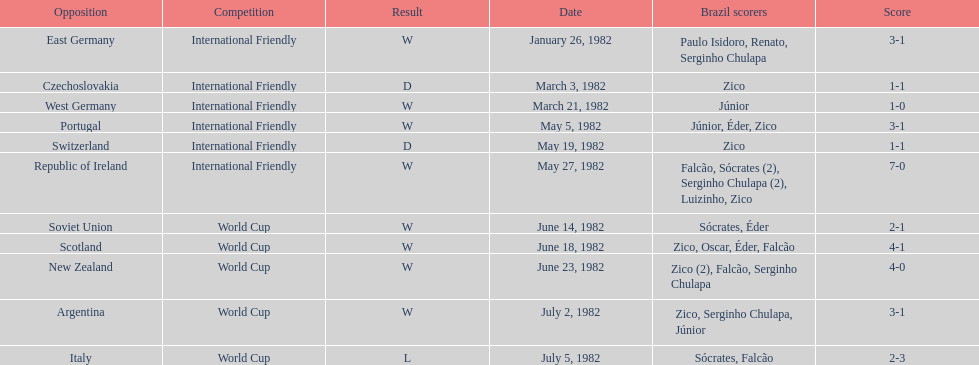Parse the full table. {'header': ['Opposition', 'Competition', 'Result', 'Date', 'Brazil scorers', 'Score'], 'rows': [['East Germany', 'International Friendly', 'W', 'January 26, 1982', 'Paulo Isidoro, Renato, Serginho Chulapa', '3-1'], ['Czechoslovakia', 'International Friendly', 'D', 'March 3, 1982', 'Zico', '1-1'], ['West Germany', 'International Friendly', 'W', 'March 21, 1982', 'Júnior', '1-0'], ['Portugal', 'International Friendly', 'W', 'May 5, 1982', 'Júnior, Éder, Zico', '3-1'], ['Switzerland', 'International Friendly', 'D', 'May 19, 1982', 'Zico', '1-1'], ['Republic of Ireland', 'International Friendly', 'W', 'May 27, 1982', 'Falcão, Sócrates (2), Serginho Chulapa (2), Luizinho, Zico', '7-0'], ['Soviet Union', 'World Cup', 'W', 'June 14, 1982', 'Sócrates, Éder', '2-1'], ['Scotland', 'World Cup', 'W', 'June 18, 1982', 'Zico, Oscar, Éder, Falcão', '4-1'], ['New Zealand', 'World Cup', 'W', 'June 23, 1982', 'Zico (2), Falcão, Serginho Chulapa', '4-0'], ['Argentina', 'World Cup', 'W', 'July 2, 1982', 'Zico, Serginho Chulapa, Júnior', '3-1'], ['Italy', 'World Cup', 'L', 'July 5, 1982', 'Sócrates, Falcão', '2-3']]} What are the dates? January 26, 1982, March 3, 1982, March 21, 1982, May 5, 1982, May 19, 1982, May 27, 1982, June 14, 1982, June 18, 1982, June 23, 1982, July 2, 1982, July 5, 1982. And which date is listed first? January 26, 1982. 